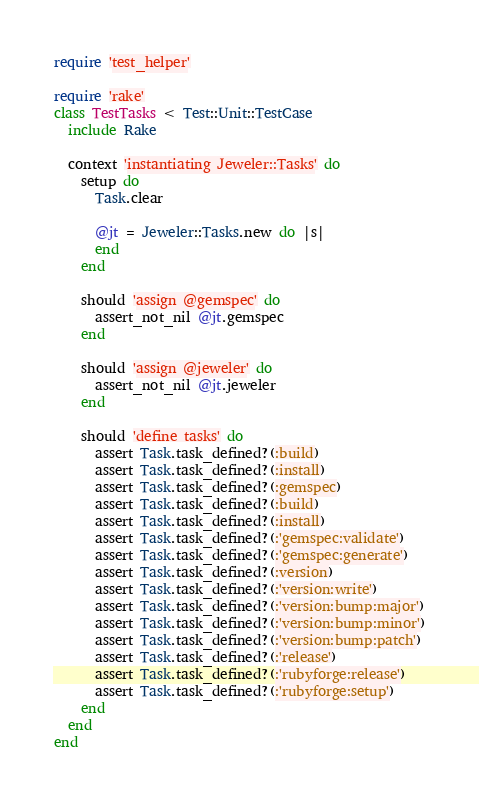Convert code to text. <code><loc_0><loc_0><loc_500><loc_500><_Ruby_>require 'test_helper'

require 'rake'
class TestTasks < Test::Unit::TestCase
  include Rake

  context 'instantiating Jeweler::Tasks' do
    setup do
      Task.clear

      @jt = Jeweler::Tasks.new do |s|
      end
    end

    should 'assign @gemspec' do
      assert_not_nil @jt.gemspec
    end

    should 'assign @jeweler' do
      assert_not_nil @jt.jeweler
    end

    should 'define tasks' do
      assert Task.task_defined?(:build)
      assert Task.task_defined?(:install)
      assert Task.task_defined?(:gemspec)
      assert Task.task_defined?(:build)
      assert Task.task_defined?(:install)
      assert Task.task_defined?(:'gemspec:validate')
      assert Task.task_defined?(:'gemspec:generate')
      assert Task.task_defined?(:version)
      assert Task.task_defined?(:'version:write')
      assert Task.task_defined?(:'version:bump:major')
      assert Task.task_defined?(:'version:bump:minor')
      assert Task.task_defined?(:'version:bump:patch')
      assert Task.task_defined?(:'release')
      assert Task.task_defined?(:'rubyforge:release')
      assert Task.task_defined?(:'rubyforge:setup')
    end
  end
end
</code> 